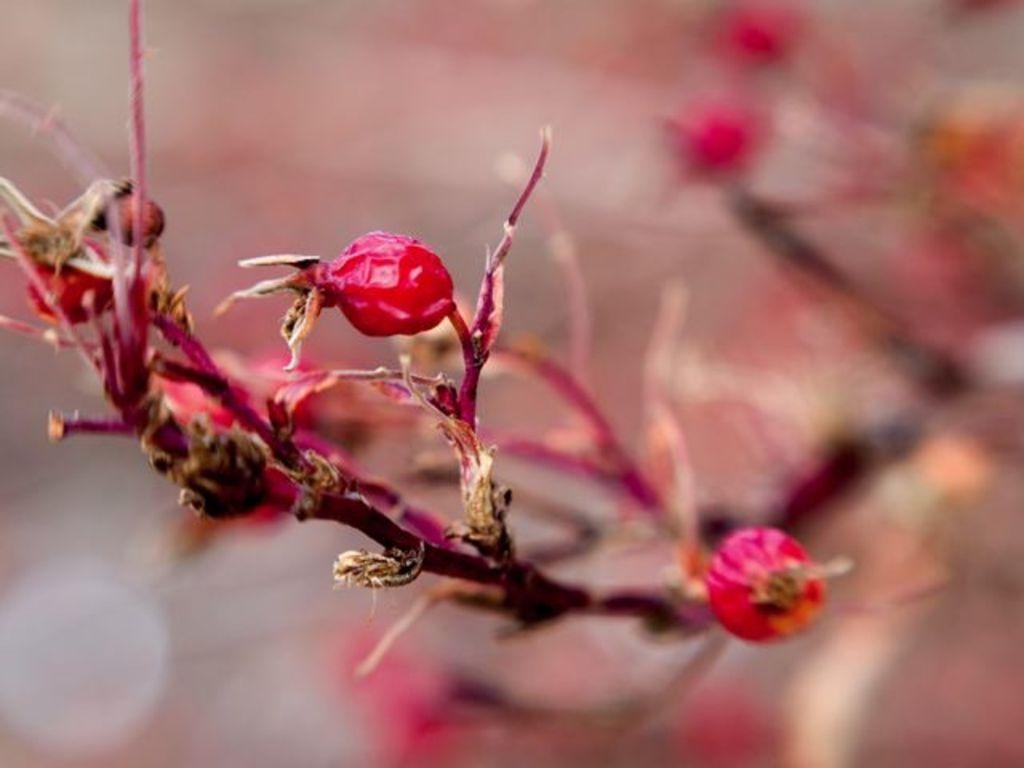What can be found on the stems in the image? There are red color things on the stems in the image. Can you describe the appearance of the red color things? Unfortunately, the provided facts do not give enough information to describe the appearance of the red color things. What can be said about the background of the image? The background of the image is blurred. How many bags of popcorn are visible in the image? There is no mention of popcorn in the provided facts, so it cannot be determined if any bags of popcorn are visible in the image. 